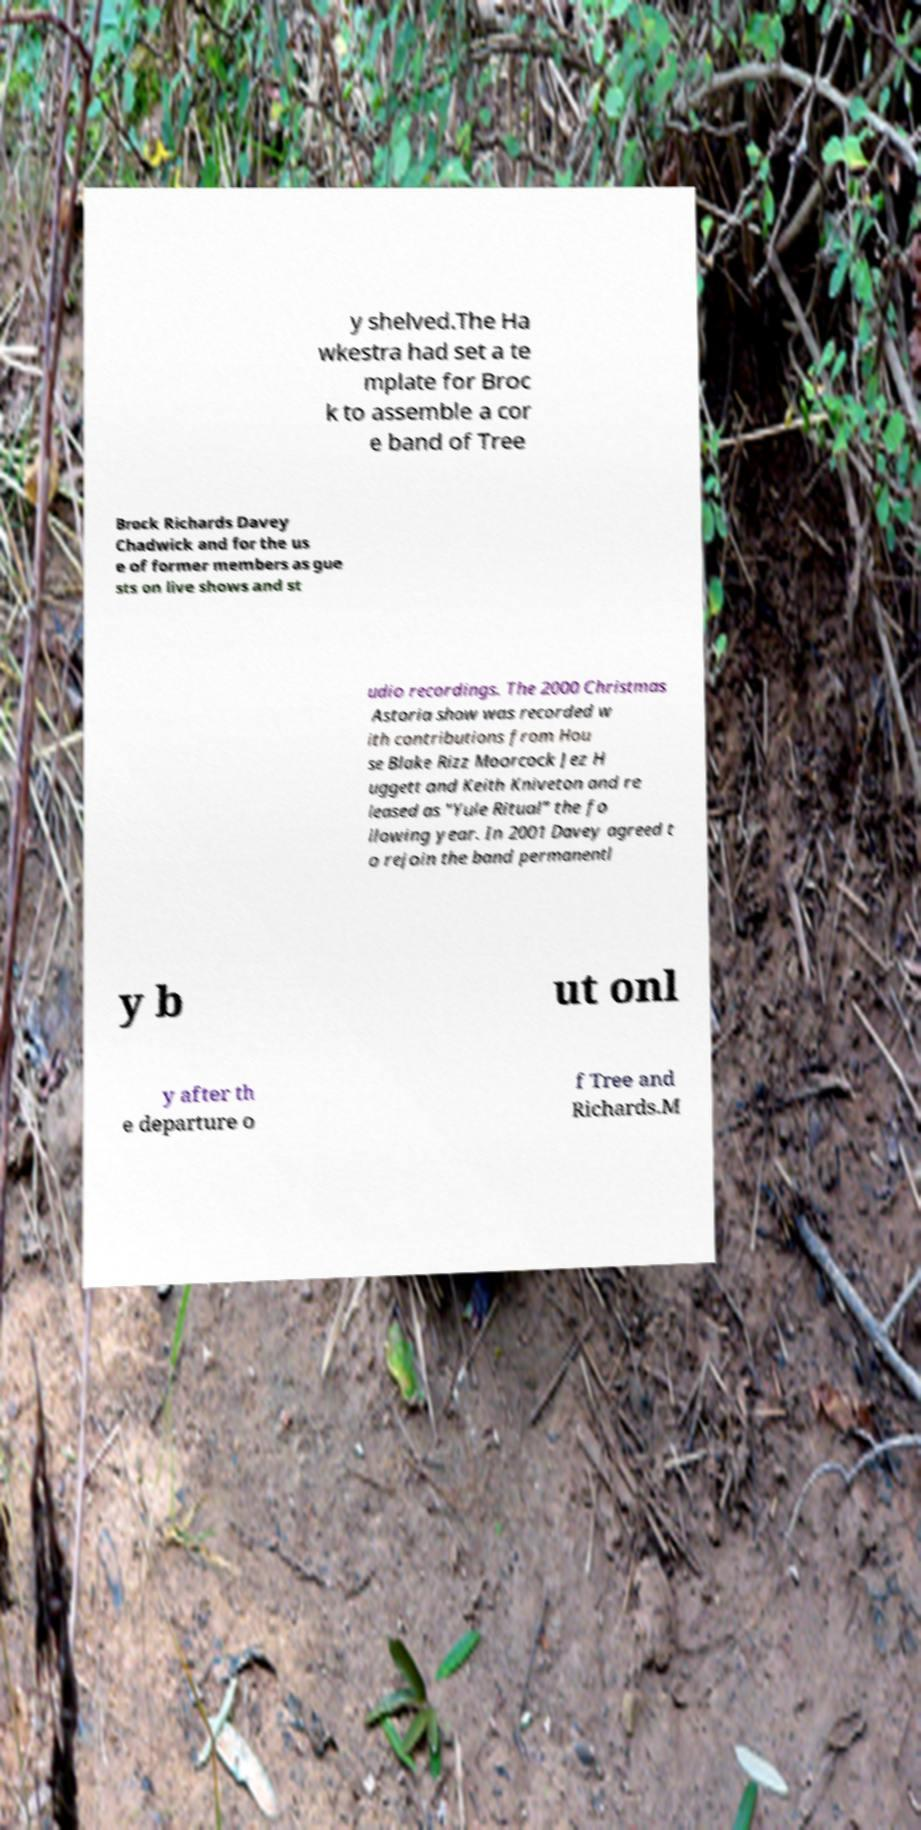I need the written content from this picture converted into text. Can you do that? y shelved.The Ha wkestra had set a te mplate for Broc k to assemble a cor e band of Tree Brock Richards Davey Chadwick and for the us e of former members as gue sts on live shows and st udio recordings. The 2000 Christmas Astoria show was recorded w ith contributions from Hou se Blake Rizz Moorcock Jez H uggett and Keith Kniveton and re leased as "Yule Ritual" the fo llowing year. In 2001 Davey agreed t o rejoin the band permanentl y b ut onl y after th e departure o f Tree and Richards.M 